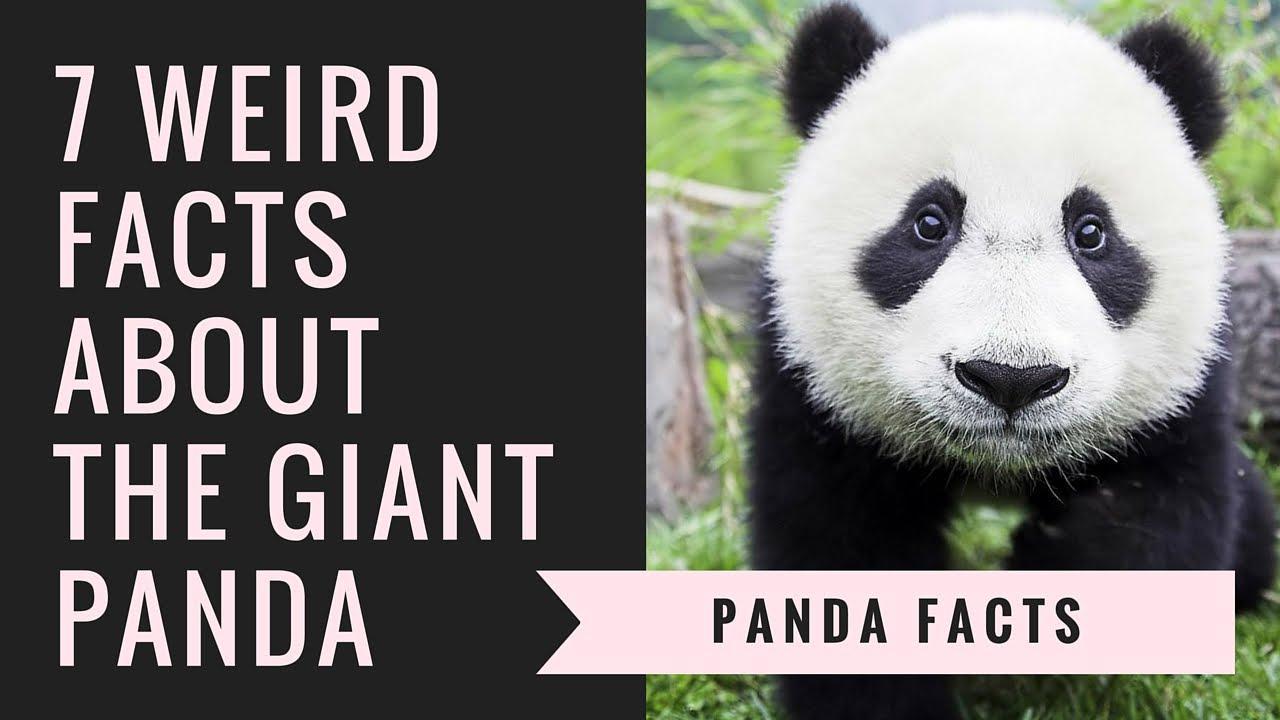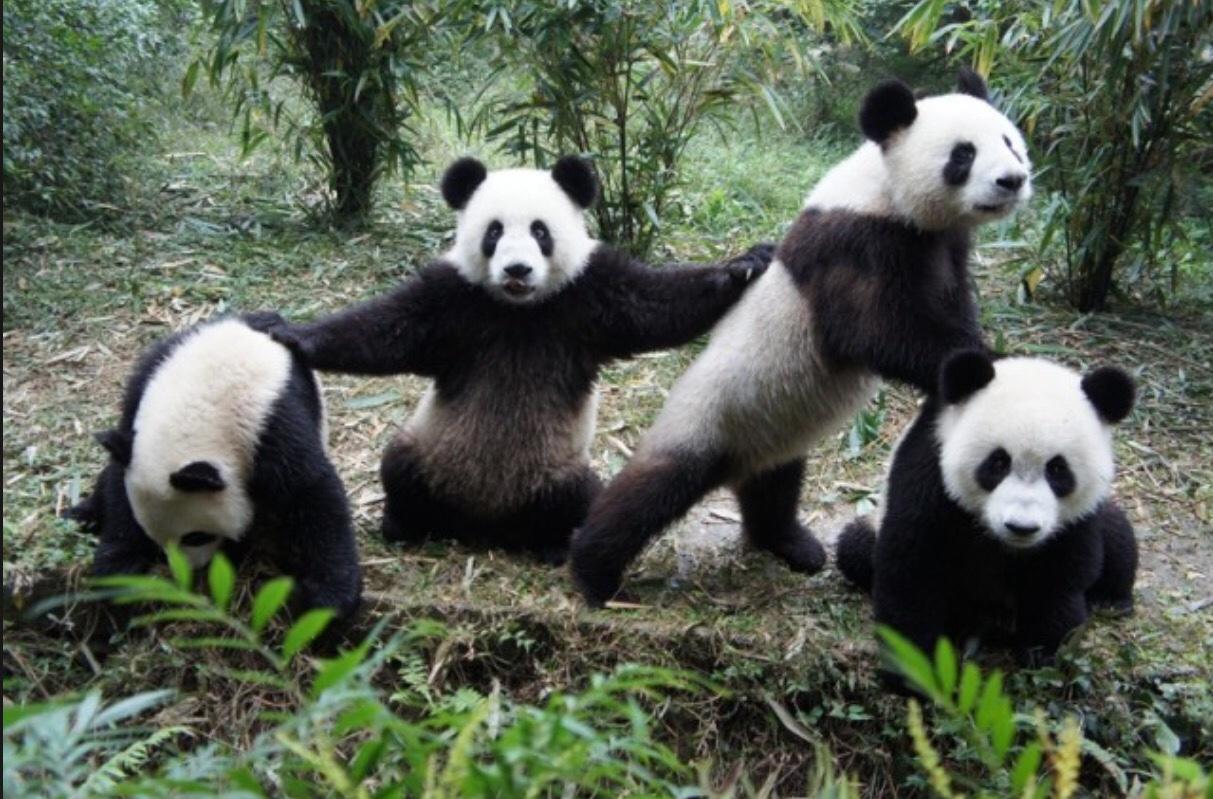The first image is the image on the left, the second image is the image on the right. Evaluate the accuracy of this statement regarding the images: "There's no more than two pandas in the right image.". Is it true? Answer yes or no. No. The first image is the image on the left, the second image is the image on the right. Examine the images to the left and right. Is the description "An image includes at least four pandas posed in a horizontal row." accurate? Answer yes or no. Yes. 